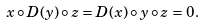Convert formula to latex. <formula><loc_0><loc_0><loc_500><loc_500>x \circ D ( y ) \circ z = D ( x ) \circ y \circ z = 0 .</formula> 